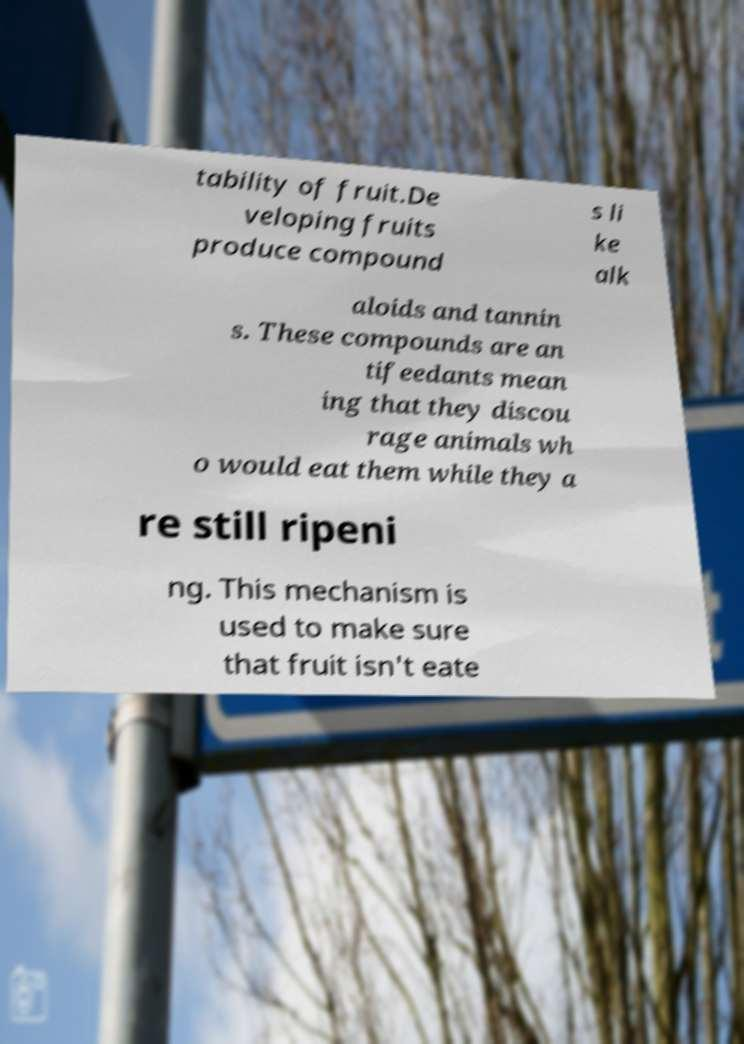I need the written content from this picture converted into text. Can you do that? tability of fruit.De veloping fruits produce compound s li ke alk aloids and tannin s. These compounds are an tifeedants mean ing that they discou rage animals wh o would eat them while they a re still ripeni ng. This mechanism is used to make sure that fruit isn't eate 